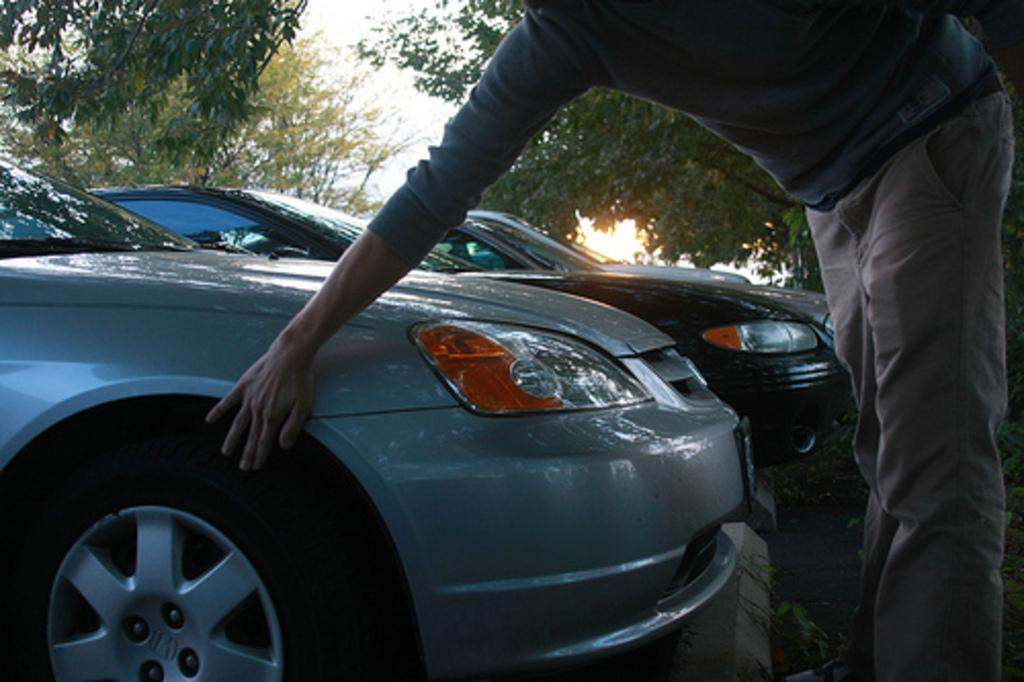What is the main subject of the image? There is a person standing in the image. What is the person doing in the image? The person is touching a vehicle. What can be seen in the background of the image? There are vehicles and trees in the background of the image. What is visible above the background? The sky is visible in the background of the image. What type of bead is the person wearing as a necklace in the image? There is no mention of a necklace or beads in the image; the person is simply touching a vehicle. Who is the person's partner in the image? There is no indication of a partner or relationship in the image; it only shows a person touching a vehicle. 